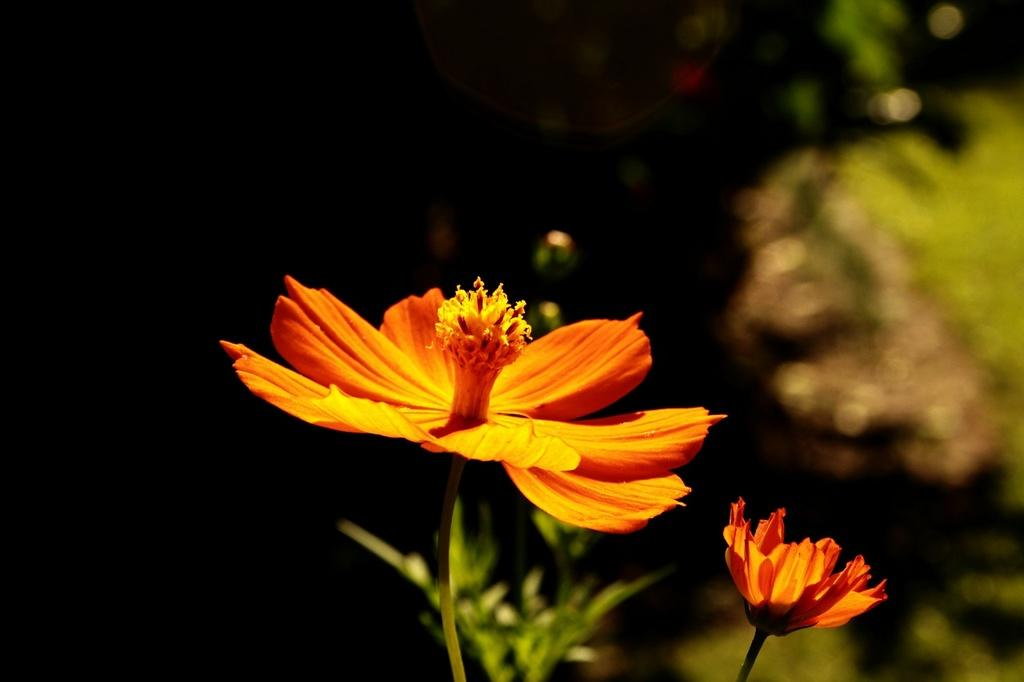What can be seen in the foreground of the image? There are flowers and green leaves in the foreground of the image. What color is the grass in the right corner of the image? The grass in the right corner of the image is green. How would you describe the background of the image? The background of the image is dark. What is the rate of the plough in the image? There is no plough present in the image, so it is not possible to determine its rate. 